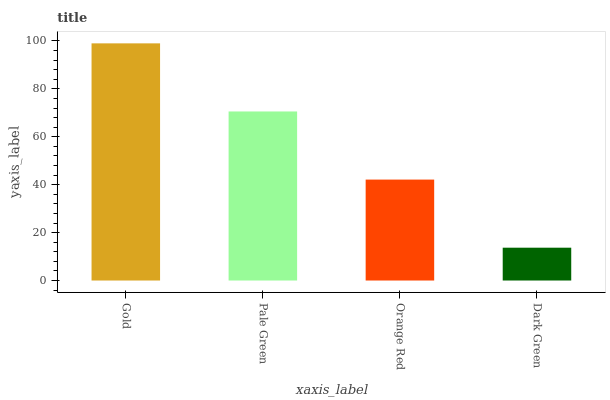Is Dark Green the minimum?
Answer yes or no. Yes. Is Gold the maximum?
Answer yes or no. Yes. Is Pale Green the minimum?
Answer yes or no. No. Is Pale Green the maximum?
Answer yes or no. No. Is Gold greater than Pale Green?
Answer yes or no. Yes. Is Pale Green less than Gold?
Answer yes or no. Yes. Is Pale Green greater than Gold?
Answer yes or no. No. Is Gold less than Pale Green?
Answer yes or no. No. Is Pale Green the high median?
Answer yes or no. Yes. Is Orange Red the low median?
Answer yes or no. Yes. Is Dark Green the high median?
Answer yes or no. No. Is Gold the low median?
Answer yes or no. No. 